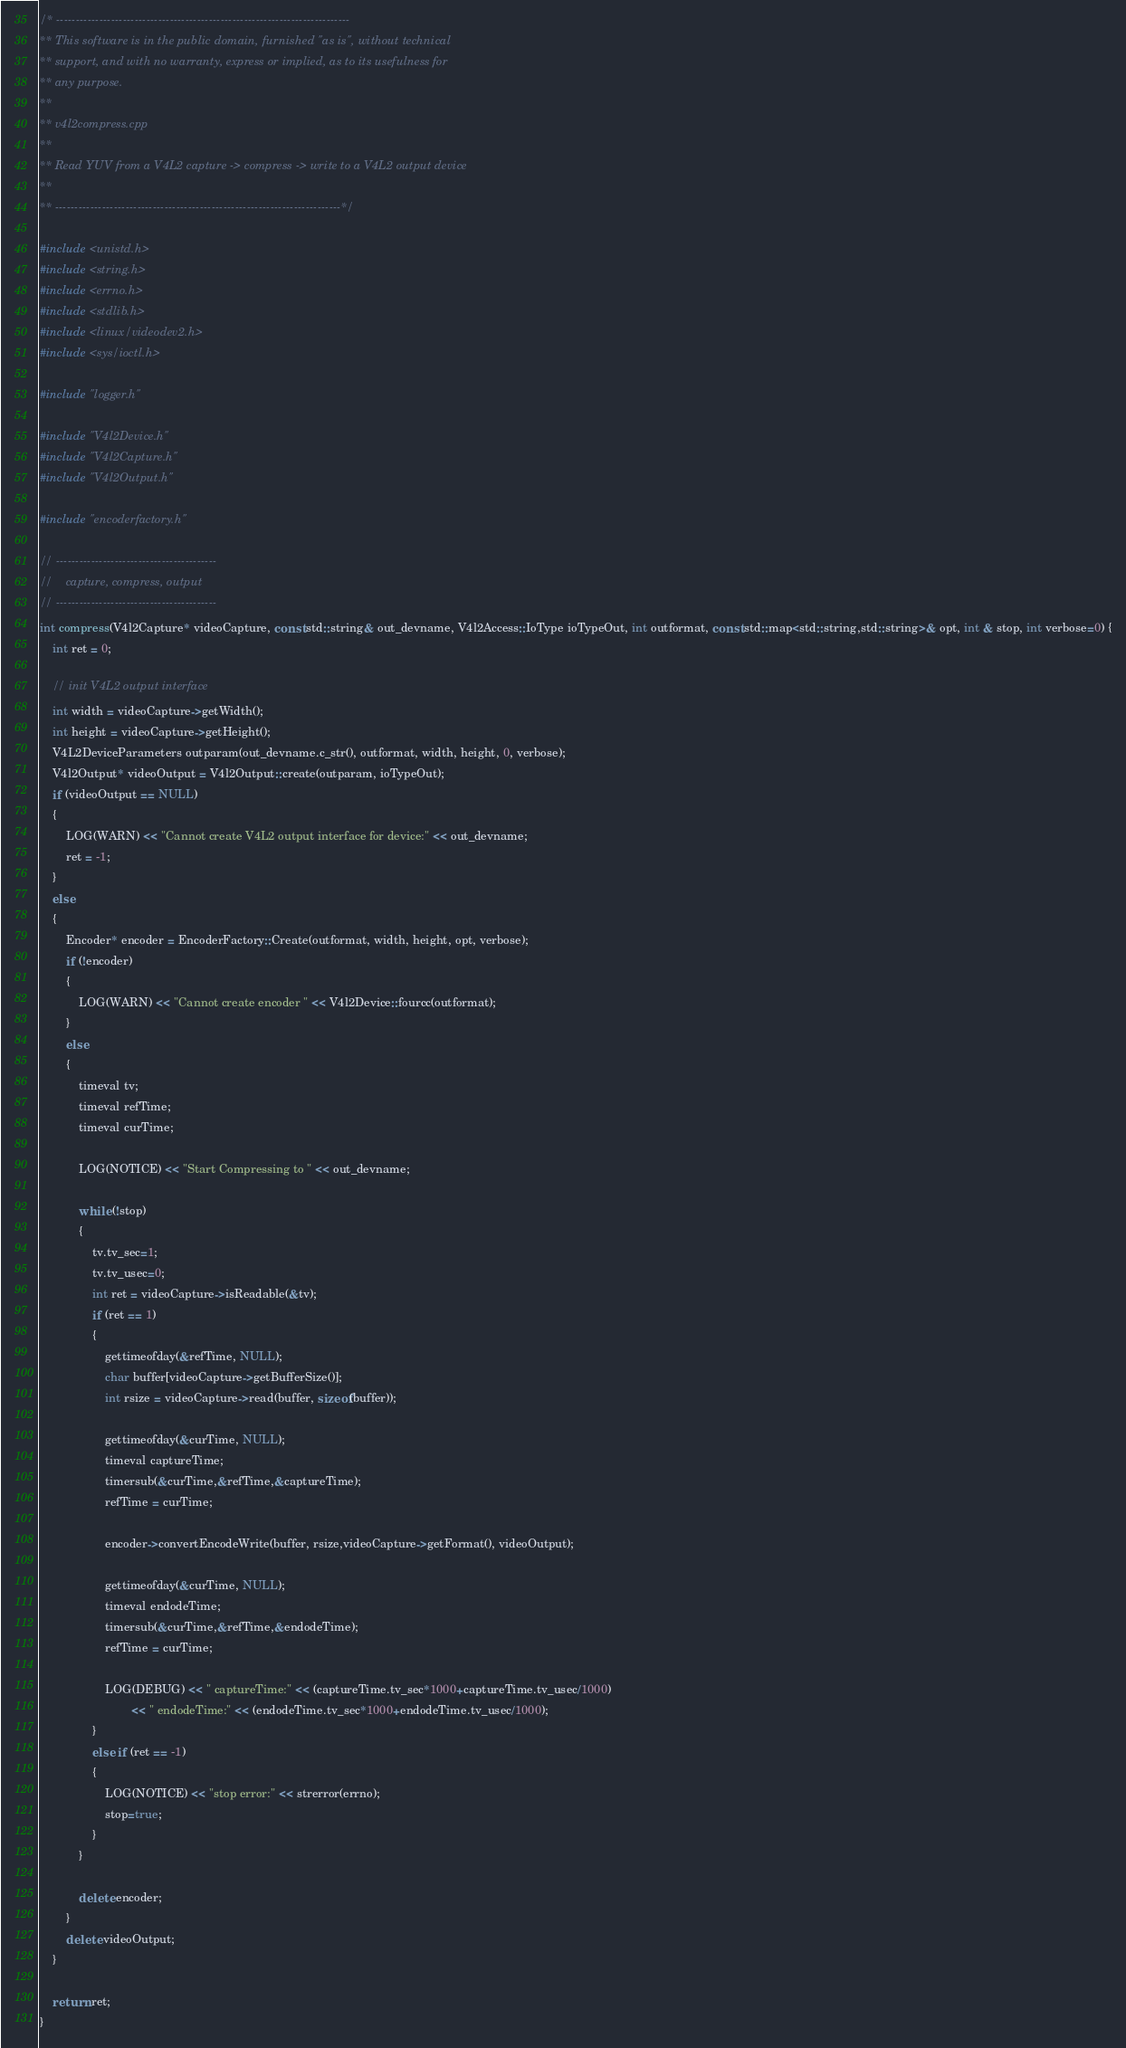Convert code to text. <code><loc_0><loc_0><loc_500><loc_500><_C++_>/* ---------------------------------------------------------------------------
** This software is in the public domain, furnished "as is", without technical
** support, and with no warranty, express or implied, as to its usefulness for
** any purpose.
**
** v4l2compress.cpp
** 
** Read YUV from a V4L2 capture -> compress -> write to a V4L2 output device
** 
** -------------------------------------------------------------------------*/

#include <unistd.h>
#include <string.h>
#include <errno.h>
#include <stdlib.h>
#include <linux/videodev2.h>
#include <sys/ioctl.h>

#include "logger.h"

#include "V4l2Device.h"
#include "V4l2Capture.h"
#include "V4l2Output.h"

#include "encoderfactory.h"

// -----------------------------------------
//    capture, compress, output 
// -----------------------------------------
int compress(V4l2Capture* videoCapture, const std::string& out_devname, V4l2Access::IoType ioTypeOut, int outformat, const std::map<std::string,std::string>& opt, int & stop, int verbose=0) {
	int ret = 0;

	// init V4L2 output interface
	int width = videoCapture->getWidth();
	int height = videoCapture->getHeight();		
	V4L2DeviceParameters outparam(out_devname.c_str(), outformat, width, height, 0, verbose);
	V4l2Output* videoOutput = V4l2Output::create(outparam, ioTypeOut);
	if (videoOutput == NULL)
	{	
		LOG(WARN) << "Cannot create V4L2 output interface for device:" << out_devname; 
		ret = -1;
	}
	else
	{		
		Encoder* encoder = EncoderFactory::Create(outformat, width, height, opt, verbose);
		if (!encoder)
		{
			LOG(WARN) << "Cannot create encoder " << V4l2Device::fourcc(outformat); 
		}
		else
		{						
			timeval tv;
			timeval refTime;
			timeval curTime;

			LOG(NOTICE) << "Start Compressing to " << out_devname;  					
			
			while (!stop) 
			{
				tv.tv_sec=1;
				tv.tv_usec=0;
				int ret = videoCapture->isReadable(&tv);
				if (ret == 1)
				{
					gettimeofday(&refTime, NULL);	
					char buffer[videoCapture->getBufferSize()];
					int rsize = videoCapture->read(buffer, sizeof(buffer));
					
					gettimeofday(&curTime, NULL);												
					timeval captureTime;
					timersub(&curTime,&refTime,&captureTime);
					refTime = curTime;
					
					encoder->convertEncodeWrite(buffer, rsize,videoCapture->getFormat(), videoOutput);

					gettimeofday(&curTime, NULL);												
					timeval endodeTime;
					timersub(&curTime,&refTime,&endodeTime);
					refTime = curTime;

					LOG(DEBUG) << " captureTime:" << (captureTime.tv_sec*1000+captureTime.tv_usec/1000) 
							<< " endodeTime:" << (endodeTime.tv_sec*1000+endodeTime.tv_usec/1000); 							
				}
				else if (ret == -1)
				{
					LOG(NOTICE) << "stop error:" << strerror(errno); 
					stop=true;
				}
			}
			
			delete encoder;
		}
		delete videoOutput;
	}

	return ret;
}

</code> 